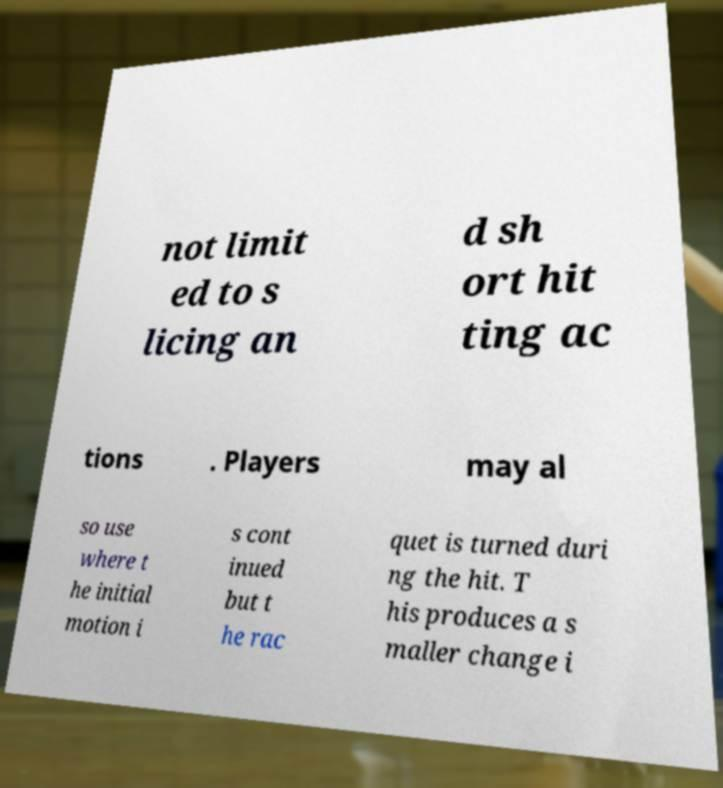What messages or text are displayed in this image? I need them in a readable, typed format. not limit ed to s licing an d sh ort hit ting ac tions . Players may al so use where t he initial motion i s cont inued but t he rac quet is turned duri ng the hit. T his produces a s maller change i 